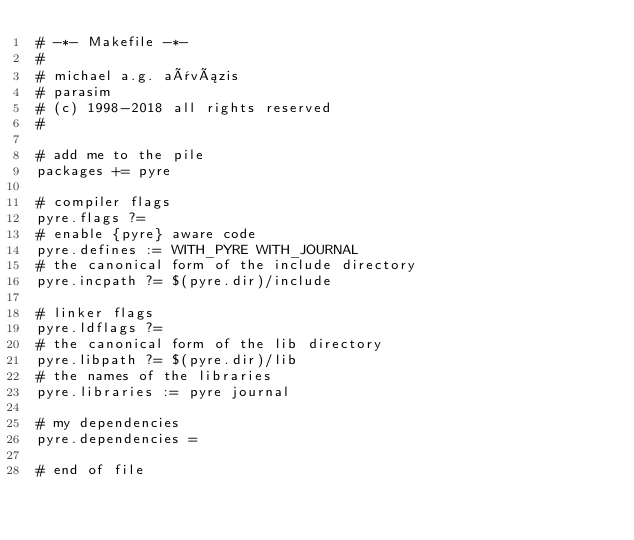Convert code to text. <code><loc_0><loc_0><loc_500><loc_500><_ObjectiveC_># -*- Makefile -*-
#
# michael a.g. aïvázis
# parasim
# (c) 1998-2018 all rights reserved
#

# add me to the pile
packages += pyre

# compiler flags
pyre.flags ?=
# enable {pyre} aware code
pyre.defines := WITH_PYRE WITH_JOURNAL
# the canonical form of the include directory
pyre.incpath ?= $(pyre.dir)/include

# linker flags
pyre.ldflags ?=
# the canonical form of the lib directory
pyre.libpath ?= $(pyre.dir)/lib
# the names of the libraries
pyre.libraries := pyre journal

# my dependencies
pyre.dependencies =

# end of file
</code> 